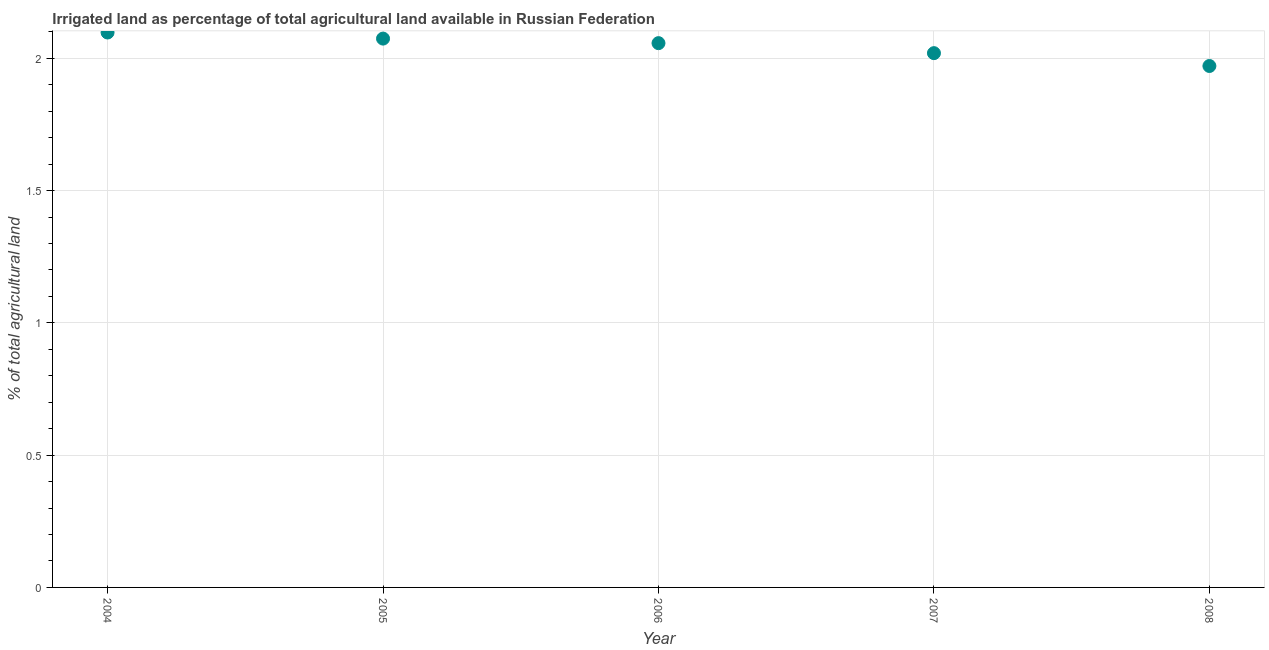What is the percentage of agricultural irrigated land in 2004?
Provide a short and direct response. 2.1. Across all years, what is the maximum percentage of agricultural irrigated land?
Offer a terse response. 2.1. Across all years, what is the minimum percentage of agricultural irrigated land?
Your answer should be compact. 1.97. What is the sum of the percentage of agricultural irrigated land?
Give a very brief answer. 10.22. What is the difference between the percentage of agricultural irrigated land in 2005 and 2007?
Make the answer very short. 0.05. What is the average percentage of agricultural irrigated land per year?
Provide a succinct answer. 2.04. What is the median percentage of agricultural irrigated land?
Give a very brief answer. 2.06. Do a majority of the years between 2005 and 2008 (inclusive) have percentage of agricultural irrigated land greater than 1.4 %?
Keep it short and to the point. Yes. What is the ratio of the percentage of agricultural irrigated land in 2004 to that in 2008?
Offer a terse response. 1.06. What is the difference between the highest and the second highest percentage of agricultural irrigated land?
Provide a short and direct response. 0.02. Is the sum of the percentage of agricultural irrigated land in 2004 and 2006 greater than the maximum percentage of agricultural irrigated land across all years?
Your answer should be compact. Yes. What is the difference between the highest and the lowest percentage of agricultural irrigated land?
Keep it short and to the point. 0.13. Does the percentage of agricultural irrigated land monotonically increase over the years?
Provide a succinct answer. No. How many dotlines are there?
Offer a very short reply. 1. How many years are there in the graph?
Provide a succinct answer. 5. Does the graph contain any zero values?
Keep it short and to the point. No. What is the title of the graph?
Make the answer very short. Irrigated land as percentage of total agricultural land available in Russian Federation. What is the label or title of the Y-axis?
Ensure brevity in your answer.  % of total agricultural land. What is the % of total agricultural land in 2004?
Give a very brief answer. 2.1. What is the % of total agricultural land in 2005?
Give a very brief answer. 2.07. What is the % of total agricultural land in 2006?
Your answer should be very brief. 2.06. What is the % of total agricultural land in 2007?
Your answer should be compact. 2.02. What is the % of total agricultural land in 2008?
Ensure brevity in your answer.  1.97. What is the difference between the % of total agricultural land in 2004 and 2005?
Make the answer very short. 0.02. What is the difference between the % of total agricultural land in 2004 and 2006?
Ensure brevity in your answer.  0.04. What is the difference between the % of total agricultural land in 2004 and 2007?
Provide a succinct answer. 0.08. What is the difference between the % of total agricultural land in 2004 and 2008?
Provide a short and direct response. 0.13. What is the difference between the % of total agricultural land in 2005 and 2006?
Your answer should be very brief. 0.02. What is the difference between the % of total agricultural land in 2005 and 2007?
Offer a terse response. 0.06. What is the difference between the % of total agricultural land in 2005 and 2008?
Offer a terse response. 0.1. What is the difference between the % of total agricultural land in 2006 and 2007?
Provide a short and direct response. 0.04. What is the difference between the % of total agricultural land in 2006 and 2008?
Offer a terse response. 0.09. What is the difference between the % of total agricultural land in 2007 and 2008?
Keep it short and to the point. 0.05. What is the ratio of the % of total agricultural land in 2004 to that in 2005?
Provide a succinct answer. 1.01. What is the ratio of the % of total agricultural land in 2004 to that in 2007?
Make the answer very short. 1.04. What is the ratio of the % of total agricultural land in 2004 to that in 2008?
Provide a short and direct response. 1.06. What is the ratio of the % of total agricultural land in 2005 to that in 2006?
Provide a succinct answer. 1.01. What is the ratio of the % of total agricultural land in 2005 to that in 2008?
Your answer should be very brief. 1.05. What is the ratio of the % of total agricultural land in 2006 to that in 2008?
Offer a very short reply. 1.04. 